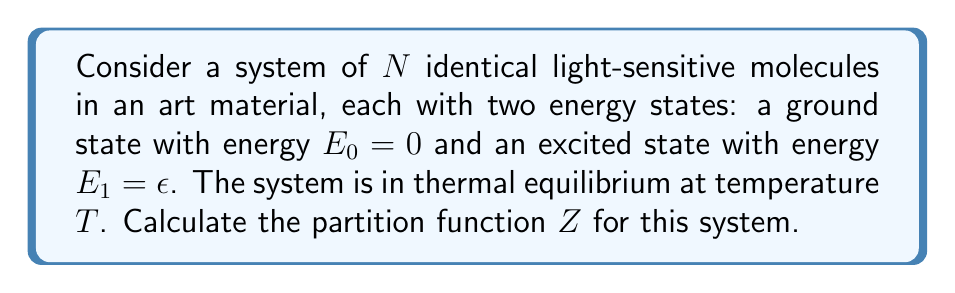What is the answer to this math problem? To solve this problem, we'll follow these steps:

1) The partition function $Z$ for a system of $N$ independent particles is given by:

   $$Z = (z)^N$$

   where $z$ is the partition function for a single particle.

2) For a single molecule with two energy states, the partition function is:

   $$z = e^{-\beta E_0} + e^{-\beta E_1}$$

   where $\beta = \frac{1}{k_B T}$, $k_B$ is the Boltzmann constant, and $T$ is the temperature.

3) Substituting the given energy values:

   $$z = e^{-\beta \cdot 0} + e^{-\beta \epsilon} = 1 + e^{-\beta \epsilon}$$

4) Now, we can calculate the partition function for the entire system:

   $$Z = (z)^N = (1 + e^{-\beta \epsilon})^N$$

5) This can be written in a more compact form using the definition of $\beta$:

   $$Z = (1 + e^{-\epsilon / k_B T})^N$$

This is the final expression for the partition function of the system.
Answer: $Z = (1 + e^{-\epsilon / k_B T})^N$ 